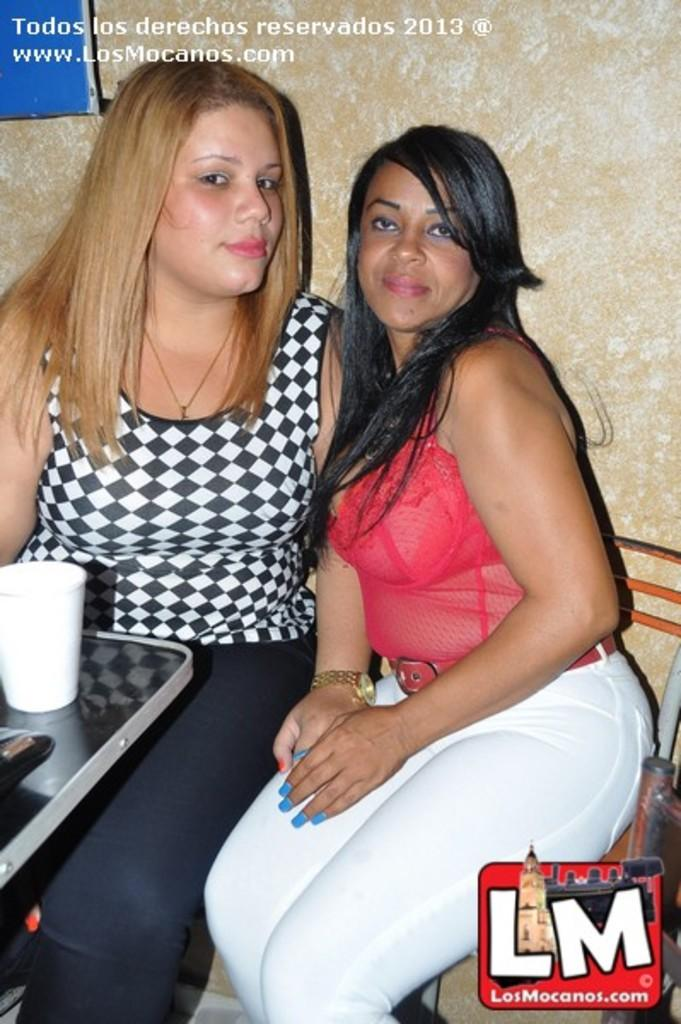How many people are sitting in the image? There are two women sitting in the image. What is present in the image besides the women? There is a table in the image. What can be seen on the table? A glass is kept on the table. Can you describe any other feature of the image? There is a watermark in the image. How many girls are playing with a pail in the image? There are no girls or pails present in the image. Are there any fairies visible in the image? There are no fairies present in the image. 